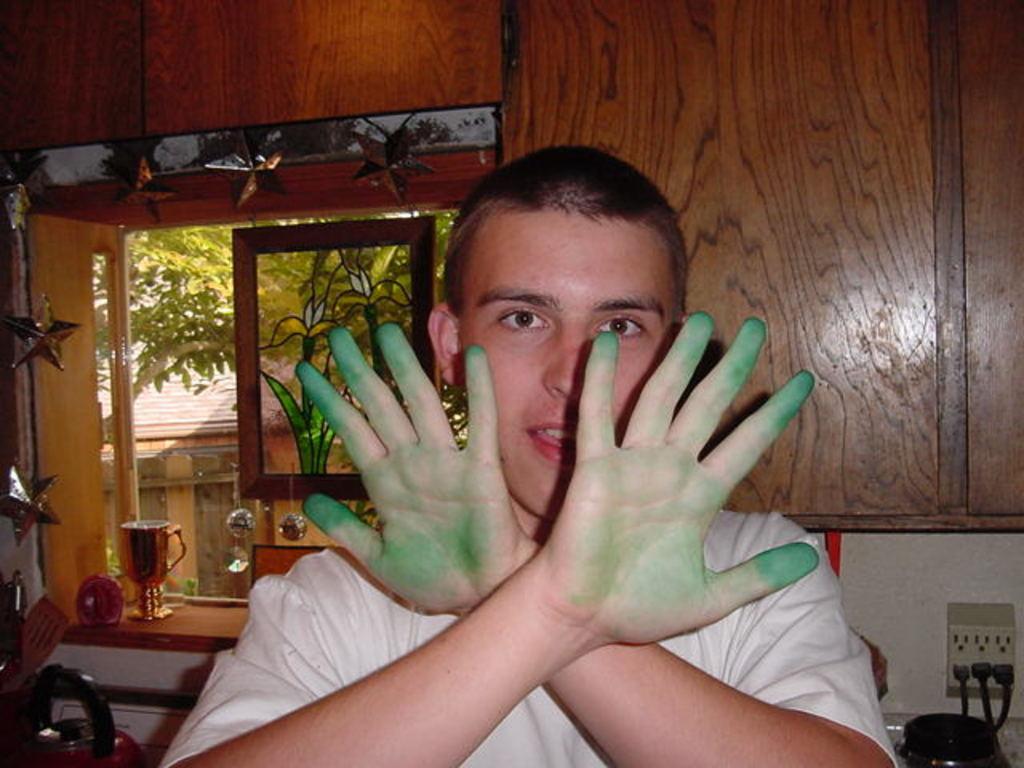In one or two sentences, can you explain what this image depicts? In this image we can see a person wearing white T-shirt is showing his hands on which we can see green color paint. Here we can see sockets fixed to the wall, we can see wooden boards, some objects, glass windows through which we can see the trees and house in the background. 